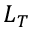Convert formula to latex. <formula><loc_0><loc_0><loc_500><loc_500>L _ { T }</formula> 